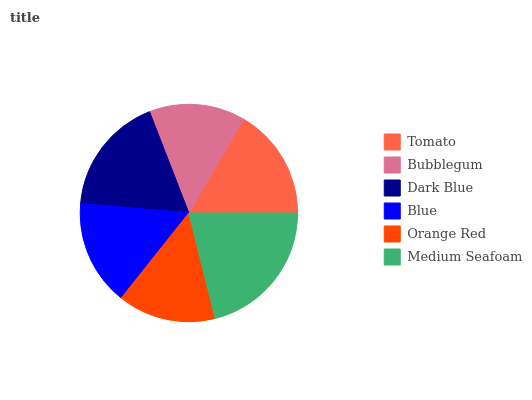Is Bubblegum the minimum?
Answer yes or no. Yes. Is Medium Seafoam the maximum?
Answer yes or no. Yes. Is Dark Blue the minimum?
Answer yes or no. No. Is Dark Blue the maximum?
Answer yes or no. No. Is Dark Blue greater than Bubblegum?
Answer yes or no. Yes. Is Bubblegum less than Dark Blue?
Answer yes or no. Yes. Is Bubblegum greater than Dark Blue?
Answer yes or no. No. Is Dark Blue less than Bubblegum?
Answer yes or no. No. Is Tomato the high median?
Answer yes or no. Yes. Is Blue the low median?
Answer yes or no. Yes. Is Blue the high median?
Answer yes or no. No. Is Tomato the low median?
Answer yes or no. No. 